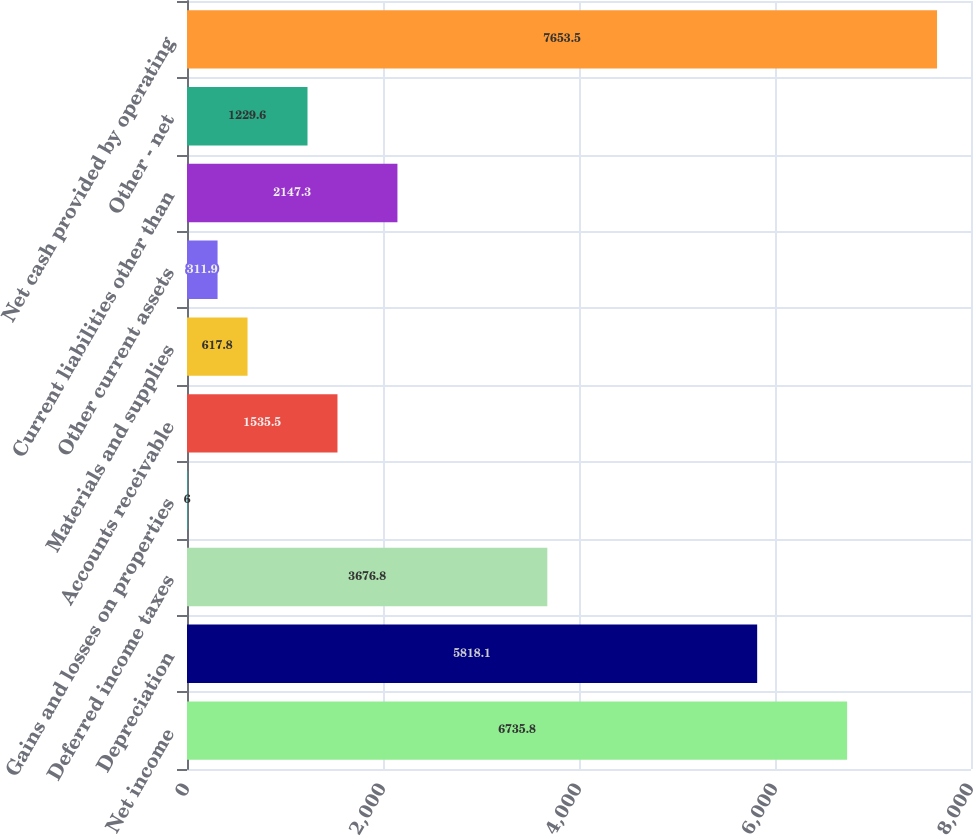<chart> <loc_0><loc_0><loc_500><loc_500><bar_chart><fcel>Net income<fcel>Depreciation<fcel>Deferred income taxes<fcel>Gains and losses on properties<fcel>Accounts receivable<fcel>Materials and supplies<fcel>Other current assets<fcel>Current liabilities other than<fcel>Other - net<fcel>Net cash provided by operating<nl><fcel>6735.8<fcel>5818.1<fcel>3676.8<fcel>6<fcel>1535.5<fcel>617.8<fcel>311.9<fcel>2147.3<fcel>1229.6<fcel>7653.5<nl></chart> 